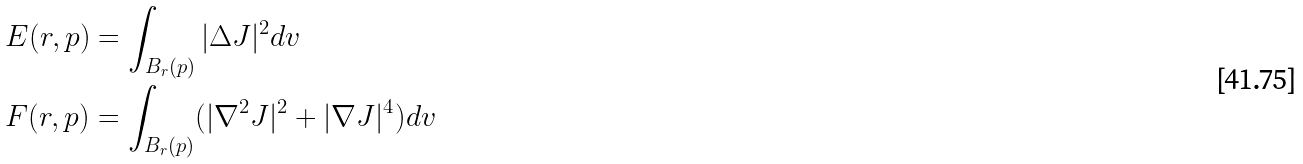Convert formula to latex. <formula><loc_0><loc_0><loc_500><loc_500>& E ( r , p ) = \int _ { B _ { r } ( p ) } | \Delta J | ^ { 2 } d v \\ & F ( r , p ) = \int _ { B _ { r } ( p ) } ( | \nabla ^ { 2 } J | ^ { 2 } + | \nabla J | ^ { 4 } ) d v</formula> 